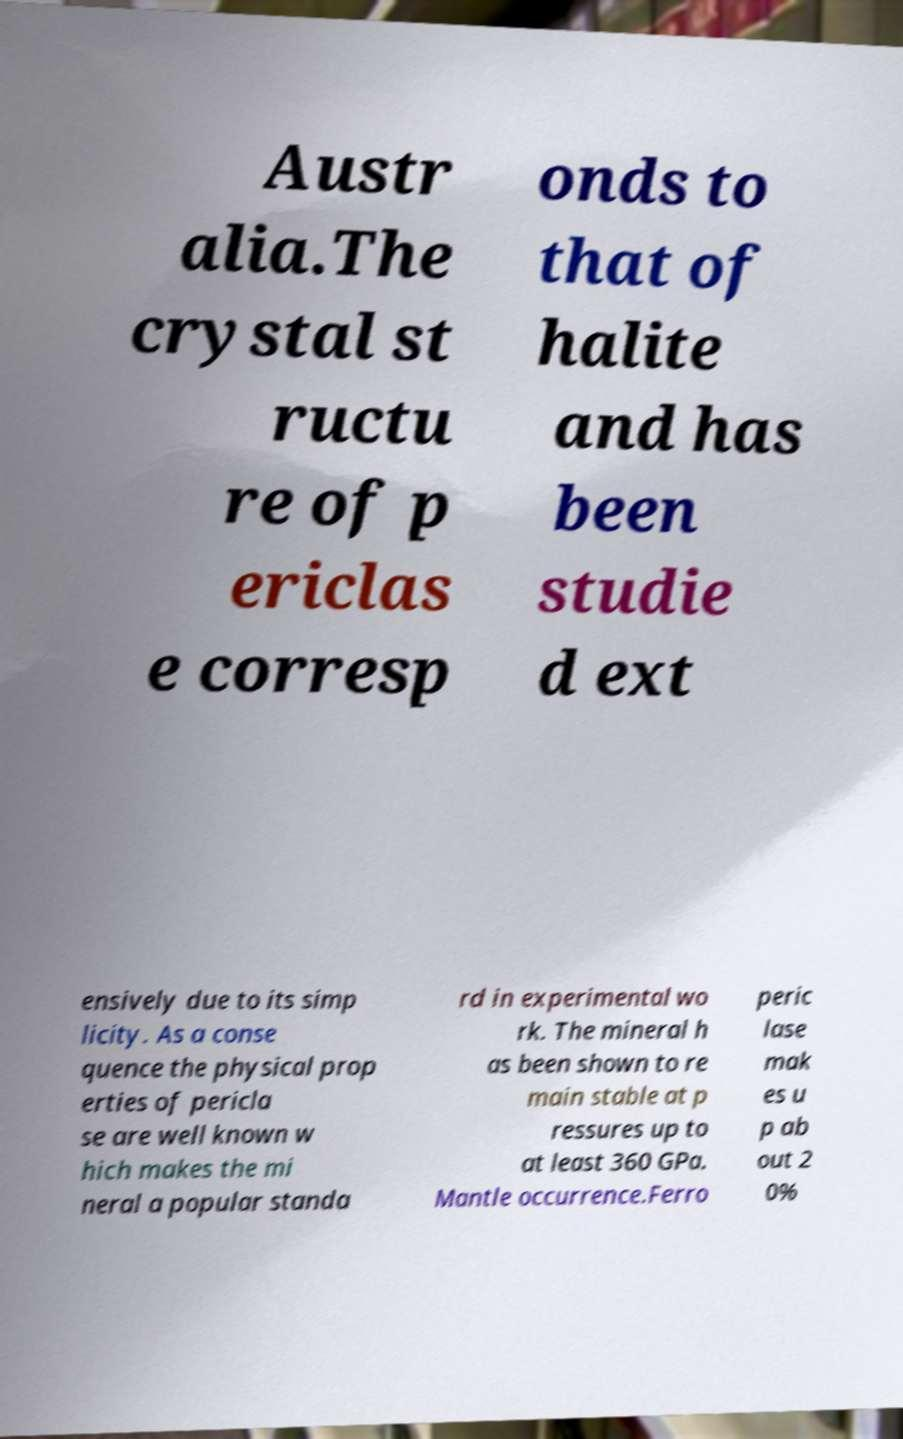What messages or text are displayed in this image? I need them in a readable, typed format. Austr alia.The crystal st ructu re of p ericlas e corresp onds to that of halite and has been studie d ext ensively due to its simp licity. As a conse quence the physical prop erties of pericla se are well known w hich makes the mi neral a popular standa rd in experimental wo rk. The mineral h as been shown to re main stable at p ressures up to at least 360 GPa. Mantle occurrence.Ferro peric lase mak es u p ab out 2 0% 